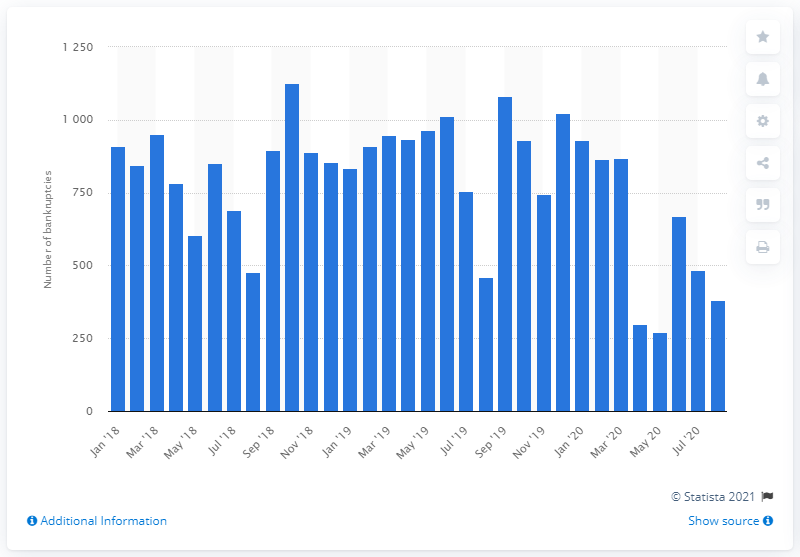Specify some key components in this picture. In August of 2020, a total of 382 companies went bankrupt. 